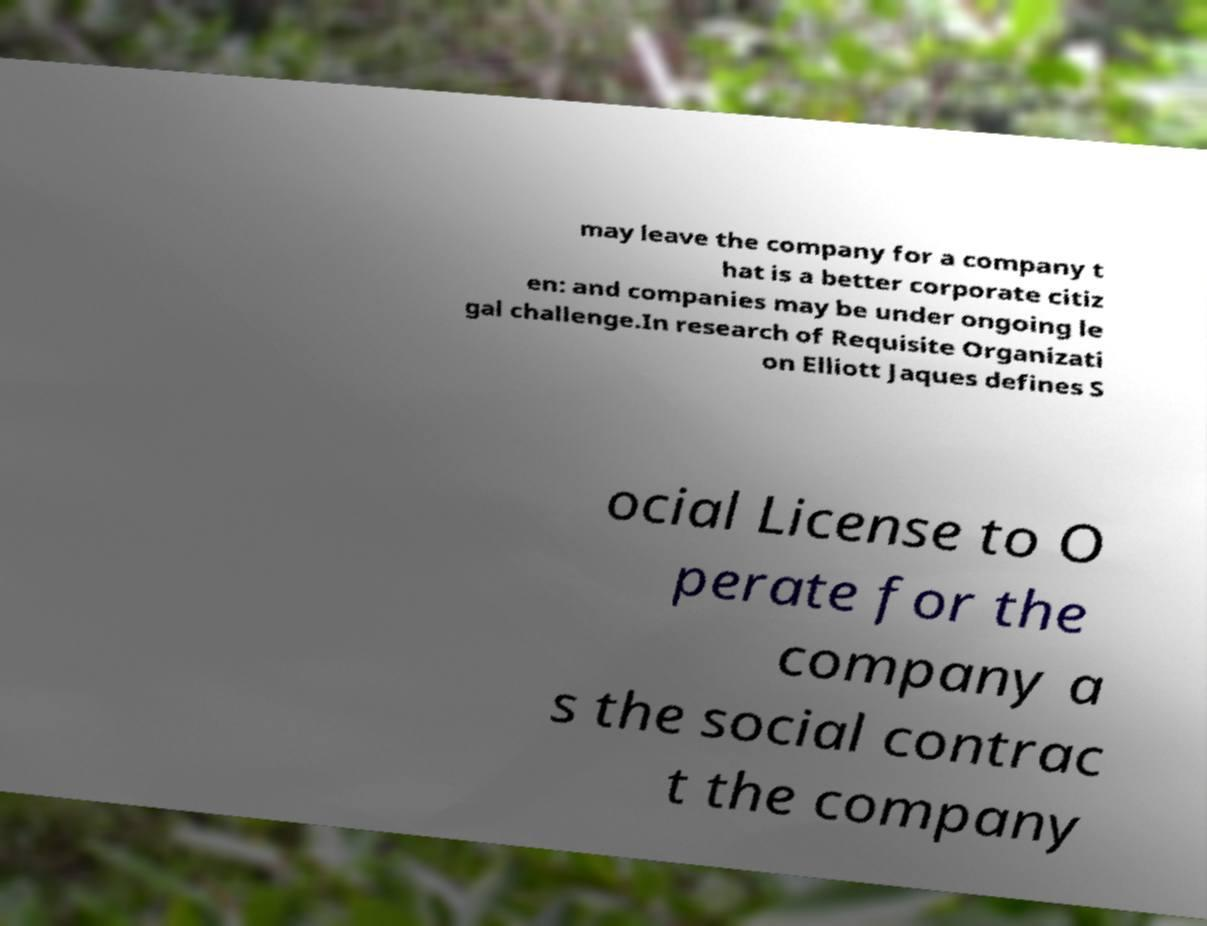Could you extract and type out the text from this image? may leave the company for a company t hat is a better corporate citiz en: and companies may be under ongoing le gal challenge.In research of Requisite Organizati on Elliott Jaques defines S ocial License to O perate for the company a s the social contrac t the company 